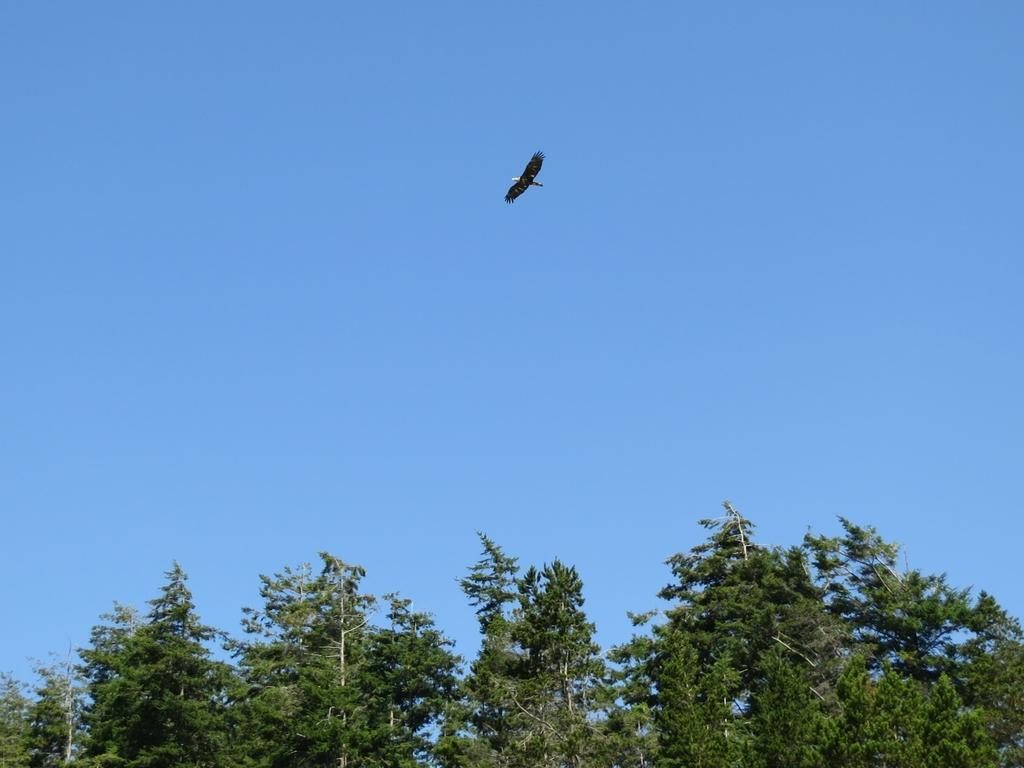What is the main feature of the image? The center of the image contains the sky. What type of vegetation can be seen in the image? Trees are present in the image. Can you describe any living creatures in the image? There is a bird flying in the image. What color is the orange hanging from the tree in the image? There is no orange present in the image; it features the sky, trees, and a bird. 